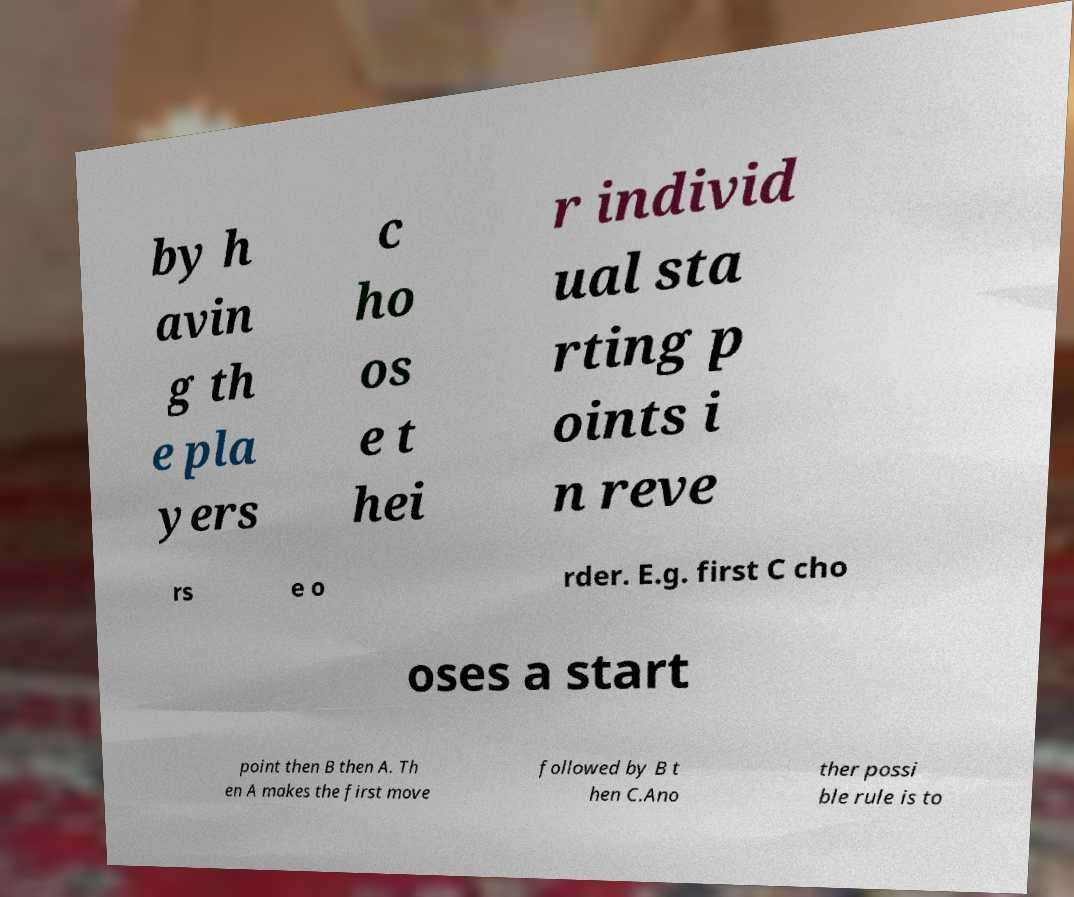Can you read and provide the text displayed in the image?This photo seems to have some interesting text. Can you extract and type it out for me? by h avin g th e pla yers c ho os e t hei r individ ual sta rting p oints i n reve rs e o rder. E.g. first C cho oses a start point then B then A. Th en A makes the first move followed by B t hen C.Ano ther possi ble rule is to 